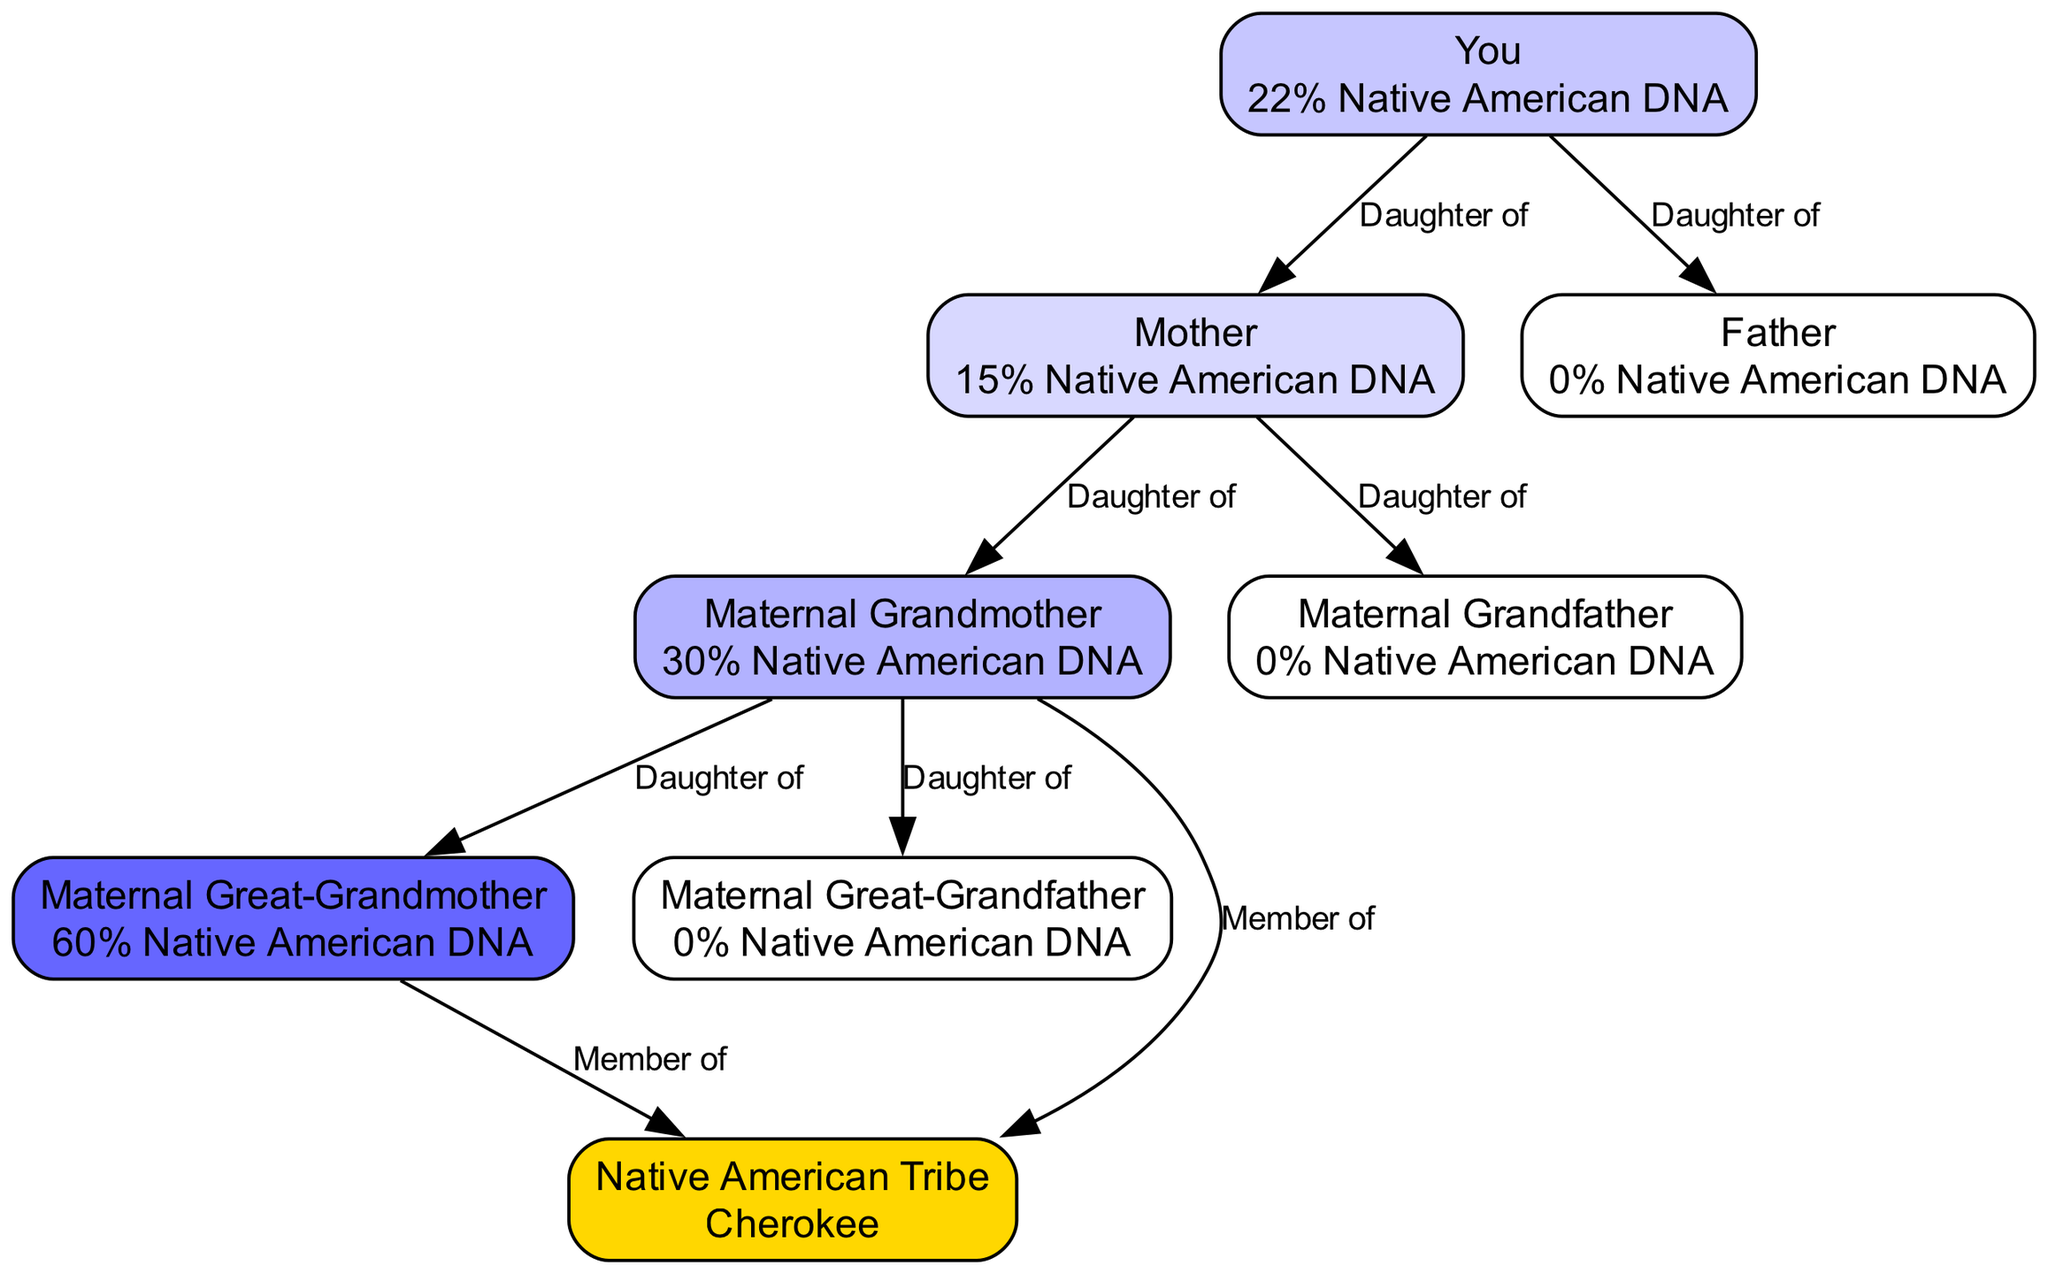What percentage of Native American DNA do you have? The diagram shows a node labeled "You" with a description of "22% Native American DNA." This indicates that you possess 22% Native American ancestry as per the DNA test results.
Answer: 22% Native American DNA Who is your mother in the diagram? In the diagram, the node labeled "Mother" is connected to "You" with the relationship "Daughter of," indicating that she is your mother.
Answer: Mother What is the percentage of Native American DNA in your maternal grandmother? The node labeled "Maternal Grandmother" shows a description of "30% Native American DNA," so this indicates her percentage of Native American ancestry based on the DNA test.
Answer: 30% Native American DNA How many edges connect the maternal grandmother to her parents? The maternal grandmother connects to two nodes—her mother and father—through the relationships "Daughter of." These connections imply that she has two parents, thus two edges in the diagram.
Answer: 2 Which tribe is associated with your Native American lineage? In the diagram, the node labeled "Native American Tribe" specifically mentions "Cherokee." This indicates the tribe linked to the family lineage concerning Native American ancestry.
Answer: Cherokee What is the total percentage of Native American DNA in your maternal great-grandmother? The node labeled "Maternal Great-Grandmother" indicates "60% Native American DNA." This represents her estimated percentage of Native American ancestry.
Answer: 60% Native American DNA Why is there 0% Native American DNA in your father? The diagram describes your "Father" with "0% Native American DNA." This means that the DNA test shows no indication of Native American ancestry on your father's side.
Answer: 0% Native American DNA Which ancestor shows the highest percentage of Native American DNA? The node for "Maternal Great-Grandmother" displays "60% Native American DNA," which is the highest percentage among all ancestors shown in the diagram.
Answer: Maternal Great-Grandmother What is the connection between your maternal grandmother and the tribe? The diagram indicates that the "Maternal Grandmother" has a relationship labeled "Member of" with the "Native American Tribe," meaning she has a direct ancestral link to the tribe as per the diagram.
Answer: Member of Cherokee 